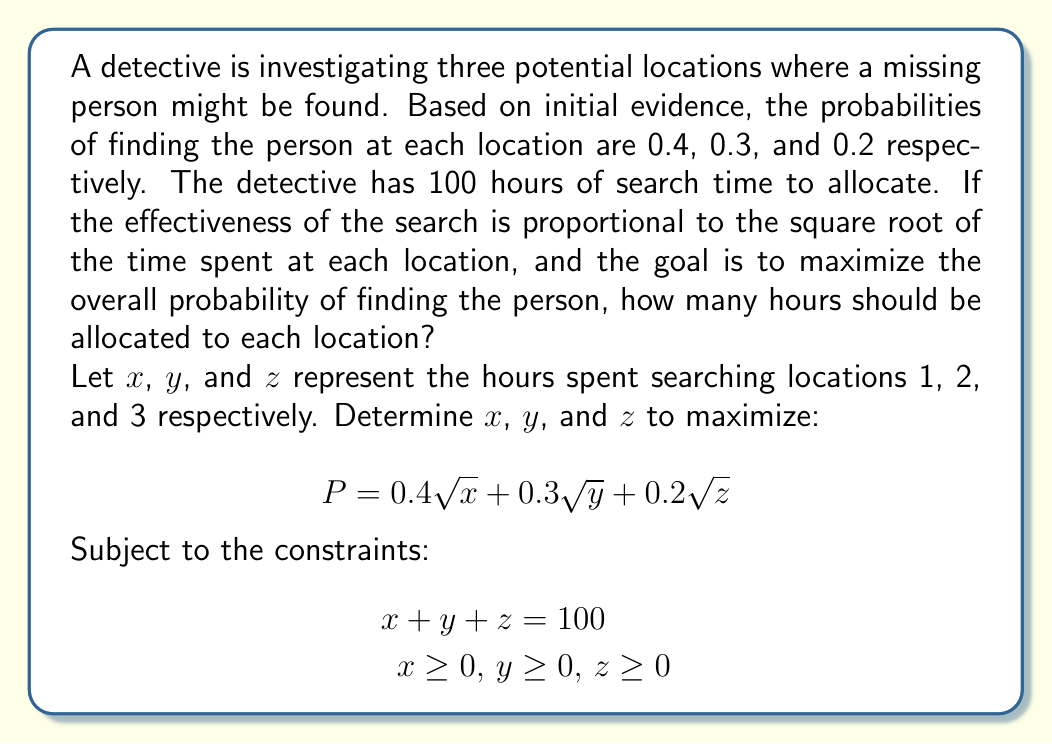What is the answer to this math problem? To solve this optimization problem, we can use the method of Lagrange multipliers:

1) Form the Lagrangian function:
   $$L = 0.4\sqrt{x} + 0.3\sqrt{y} + 0.2\sqrt{z} + \lambda(100 - x - y - z)$$

2) Take partial derivatives and set them equal to zero:
   $$\frac{\partial L}{\partial x} = \frac{0.2}{\sqrt{x}} - \lambda = 0$$
   $$\frac{\partial L}{\partial y} = \frac{0.15}{\sqrt{y}} - \lambda = 0$$
   $$\frac{\partial L}{\partial z} = \frac{0.1}{\sqrt{z}} - \lambda = 0$$
   $$\frac{\partial L}{\partial \lambda} = 100 - x - y - z = 0$$

3) From these equations, we can deduce:
   $$\frac{0.2}{\sqrt{x}} = \frac{0.15}{\sqrt{y}} = \frac{0.1}{\sqrt{z}} = \lambda$$

4) This implies:
   $$\frac{x}{(0.2)^2} = \frac{y}{(0.15)^2} = \frac{z}{(0.1)^2}$$

5) Let's denote $\frac{x}{(0.2)^2} = k$. Then:
   $$x = 0.04k, y = 0.0225k, z = 0.01k$$

6) Substituting these into the constraint equation:
   $$0.04k + 0.0225k + 0.01k = 100$$
   $$0.0725k = 100$$
   $$k = 1379.31$$

7) Now we can solve for x, y, and z:
   $$x = 0.04 * 1379.31 = 55.17$$
   $$y = 0.0225 * 1379.31 = 31.03$$
   $$z = 0.01 * 1379.31 = 13.79$$

8) Rounding to the nearest hour:
   $$x = 55, y = 31, z = 14$$
Answer: 55 hours at location 1, 31 hours at location 2, 14 hours at location 3 